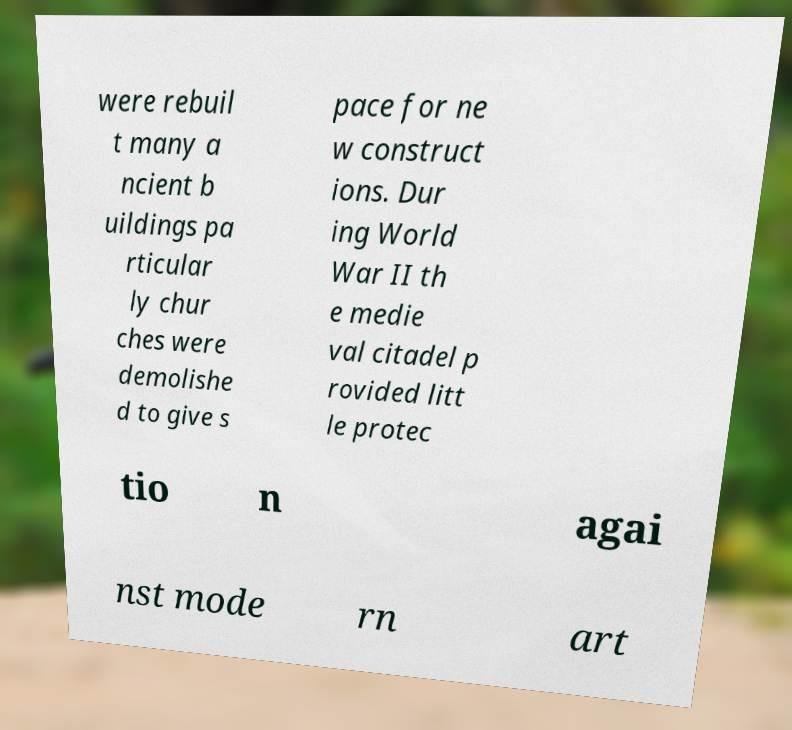I need the written content from this picture converted into text. Can you do that? were rebuil t many a ncient b uildings pa rticular ly chur ches were demolishe d to give s pace for ne w construct ions. Dur ing World War II th e medie val citadel p rovided litt le protec tio n agai nst mode rn art 